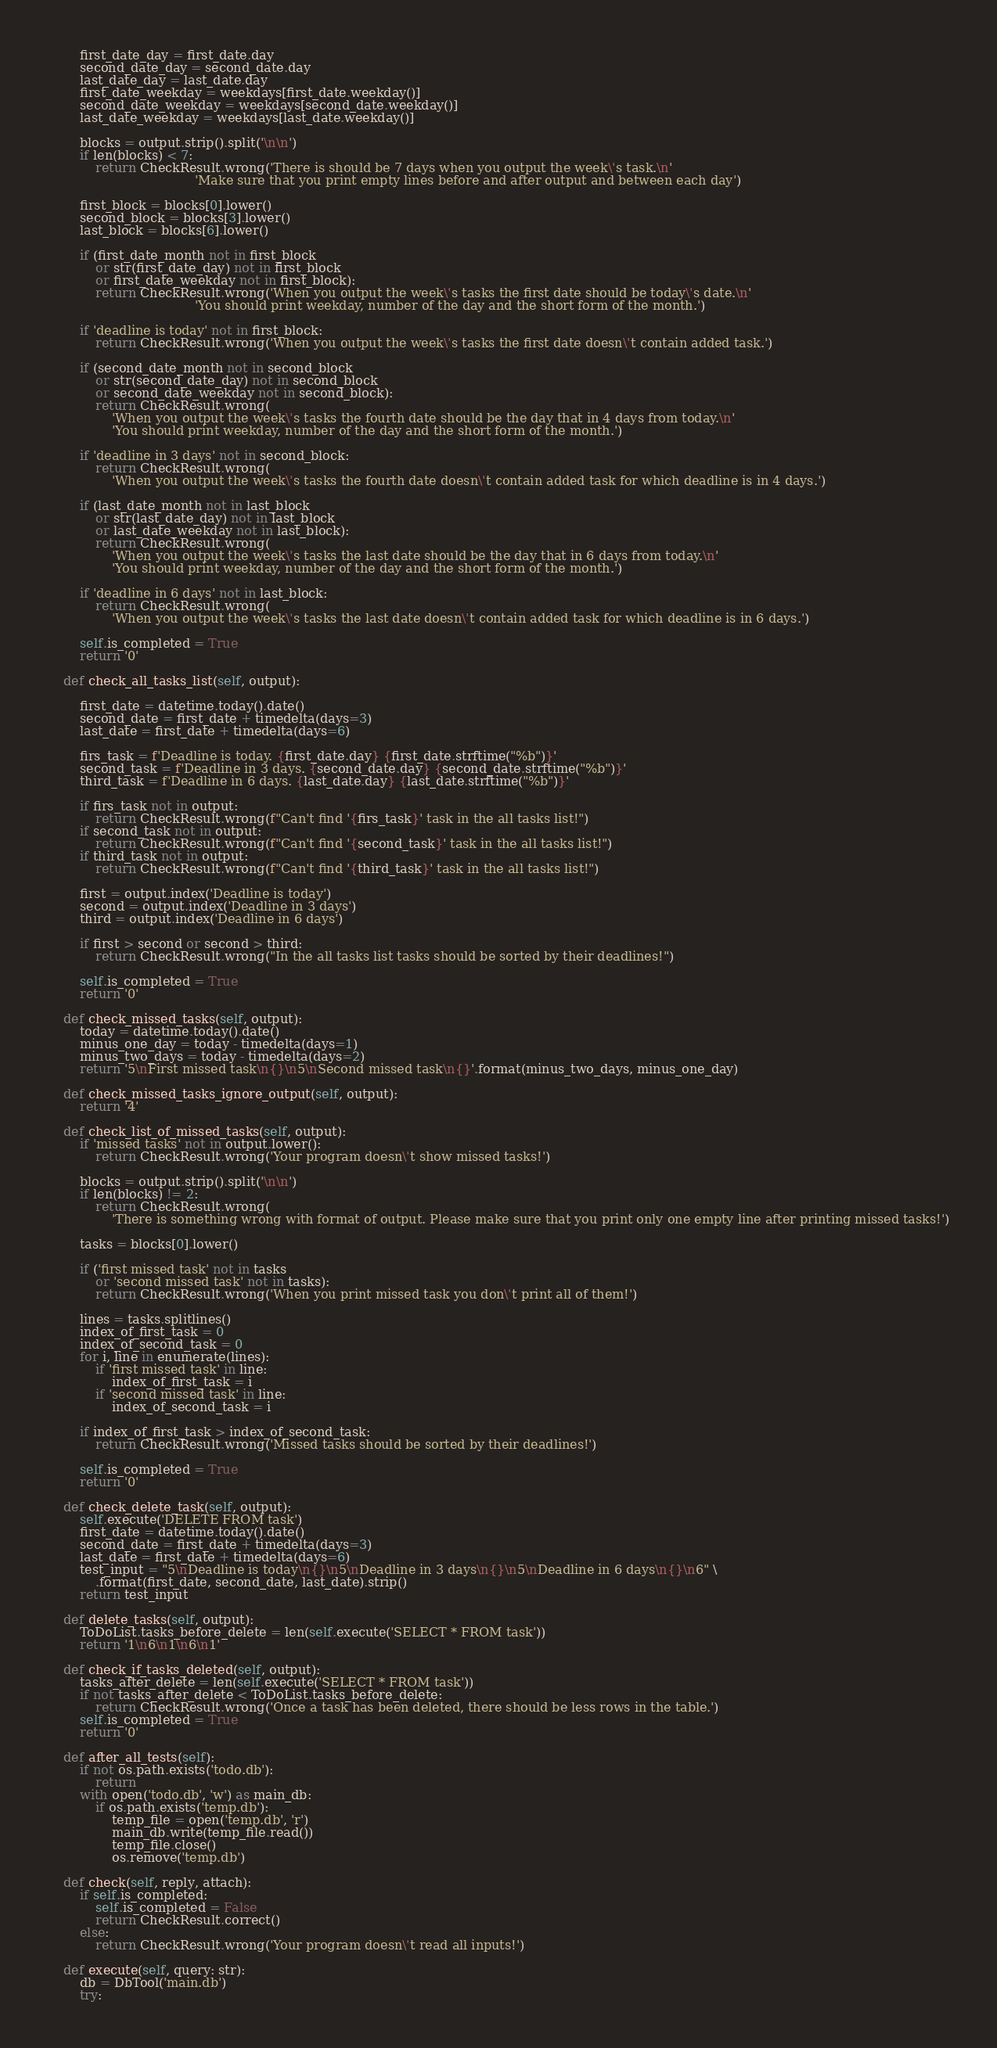<code> <loc_0><loc_0><loc_500><loc_500><_Python_>        first_date_day = first_date.day
        second_date_day = second_date.day
        last_date_day = last_date.day
        first_date_weekday = weekdays[first_date.weekday()]
        second_date_weekday = weekdays[second_date.weekday()]
        last_date_weekday = weekdays[last_date.weekday()]

        blocks = output.strip().split('\n\n')
        if len(blocks) < 7:
            return CheckResult.wrong('There is should be 7 days when you output the week\'s task.\n'
                                     'Make sure that you print empty lines before and after output and between each day')

        first_block = blocks[0].lower()
        second_block = blocks[3].lower()
        last_block = blocks[6].lower()

        if (first_date_month not in first_block
            or str(first_date_day) not in first_block
            or first_date_weekday not in first_block):
            return CheckResult.wrong('When you output the week\'s tasks the first date should be today\'s date.\n'
                                     'You should print weekday, number of the day and the short form of the month.')

        if 'deadline is today' not in first_block:
            return CheckResult.wrong('When you output the week\'s tasks the first date doesn\'t contain added task.')

        if (second_date_month not in second_block
            or str(second_date_day) not in second_block
            or second_date_weekday not in second_block):
            return CheckResult.wrong(
                'When you output the week\'s tasks the fourth date should be the day that in 4 days from today.\n'
                'You should print weekday, number of the day and the short form of the month.')

        if 'deadline in 3 days' not in second_block:
            return CheckResult.wrong(
                'When you output the week\'s tasks the fourth date doesn\'t contain added task for which deadline is in 4 days.')

        if (last_date_month not in last_block
            or str(last_date_day) not in last_block
            or last_date_weekday not in last_block):
            return CheckResult.wrong(
                'When you output the week\'s tasks the last date should be the day that in 6 days from today.\n'
                'You should print weekday, number of the day and the short form of the month.')

        if 'deadline in 6 days' not in last_block:
            return CheckResult.wrong(
                'When you output the week\'s tasks the last date doesn\'t contain added task for which deadline is in 6 days.')

        self.is_completed = True
        return '0'

    def check_all_tasks_list(self, output):

        first_date = datetime.today().date()
        second_date = first_date + timedelta(days=3)
        last_date = first_date + timedelta(days=6)

        firs_task = f'Deadline is today. {first_date.day} {first_date.strftime("%b")}'
        second_task = f'Deadline in 3 days. {second_date.day} {second_date.strftime("%b")}'
        third_task = f'Deadline in 6 days. {last_date.day} {last_date.strftime("%b")}'

        if firs_task not in output:
            return CheckResult.wrong(f"Can't find '{firs_task}' task in the all tasks list!")
        if second_task not in output:
            return CheckResult.wrong(f"Can't find '{second_task}' task in the all tasks list!")
        if third_task not in output:
            return CheckResult.wrong(f"Can't find '{third_task}' task in the all tasks list!")

        first = output.index('Deadline is today')
        second = output.index('Deadline in 3 days')
        third = output.index('Deadline in 6 days')

        if first > second or second > third:
            return CheckResult.wrong("In the all tasks list tasks should be sorted by their deadlines!")

        self.is_completed = True
        return '0'

    def check_missed_tasks(self, output):
        today = datetime.today().date()
        minus_one_day = today - timedelta(days=1)
        minus_two_days = today - timedelta(days=2)
        return '5\nFirst missed task\n{}\n5\nSecond missed task\n{}'.format(minus_two_days, minus_one_day)

    def check_missed_tasks_ignore_output(self, output):
        return '4'

    def check_list_of_missed_tasks(self, output):
        if 'missed tasks' not in output.lower():
            return CheckResult.wrong('Your program doesn\'t show missed tasks!')

        blocks = output.strip().split('\n\n')
        if len(blocks) != 2:
            return CheckResult.wrong(
                'There is something wrong with format of output. Please make sure that you print only one empty line after printing missed tasks!')

        tasks = blocks[0].lower()

        if ('first missed task' not in tasks
            or 'second missed task' not in tasks):
            return CheckResult.wrong('When you print missed task you don\'t print all of them!')

        lines = tasks.splitlines()
        index_of_first_task = 0
        index_of_second_task = 0
        for i, line in enumerate(lines):
            if 'first missed task' in line:
                index_of_first_task = i
            if 'second missed task' in line:
                index_of_second_task = i

        if index_of_first_task > index_of_second_task:
            return CheckResult.wrong('Missed tasks should be sorted by their deadlines!')

        self.is_completed = True
        return '0'

    def check_delete_task(self, output):
        self.execute('DELETE FROM task')
        first_date = datetime.today().date()
        second_date = first_date + timedelta(days=3)
        last_date = first_date + timedelta(days=6)
        test_input = "5\nDeadline is today\n{}\n5\nDeadline in 3 days\n{}\n5\nDeadline in 6 days\n{}\n6" \
            .format(first_date, second_date, last_date).strip()
        return test_input

    def delete_tasks(self, output):
        ToDoList.tasks_before_delete = len(self.execute('SELECT * FROM task'))
        return '1\n6\n1\n6\n1'

    def check_if_tasks_deleted(self, output):
        tasks_after_delete = len(self.execute('SELECT * FROM task'))
        if not tasks_after_delete < ToDoList.tasks_before_delete:
            return CheckResult.wrong('Once a task has been deleted, there should be less rows in the table.')
        self.is_completed = True
        return '0'

    def after_all_tests(self):
        if not os.path.exists('todo.db'):
            return
        with open('todo.db', 'w') as main_db:
            if os.path.exists('temp.db'):
                temp_file = open('temp.db', 'r')
                main_db.write(temp_file.read())
                temp_file.close()
                os.remove('temp.db')

    def check(self, reply, attach):
        if self.is_completed:
            self.is_completed = False
            return CheckResult.correct()
        else:
            return CheckResult.wrong('Your program doesn\'t read all inputs!')

    def execute(self, query: str):
        db = DbTool('main.db')
        try:</code> 